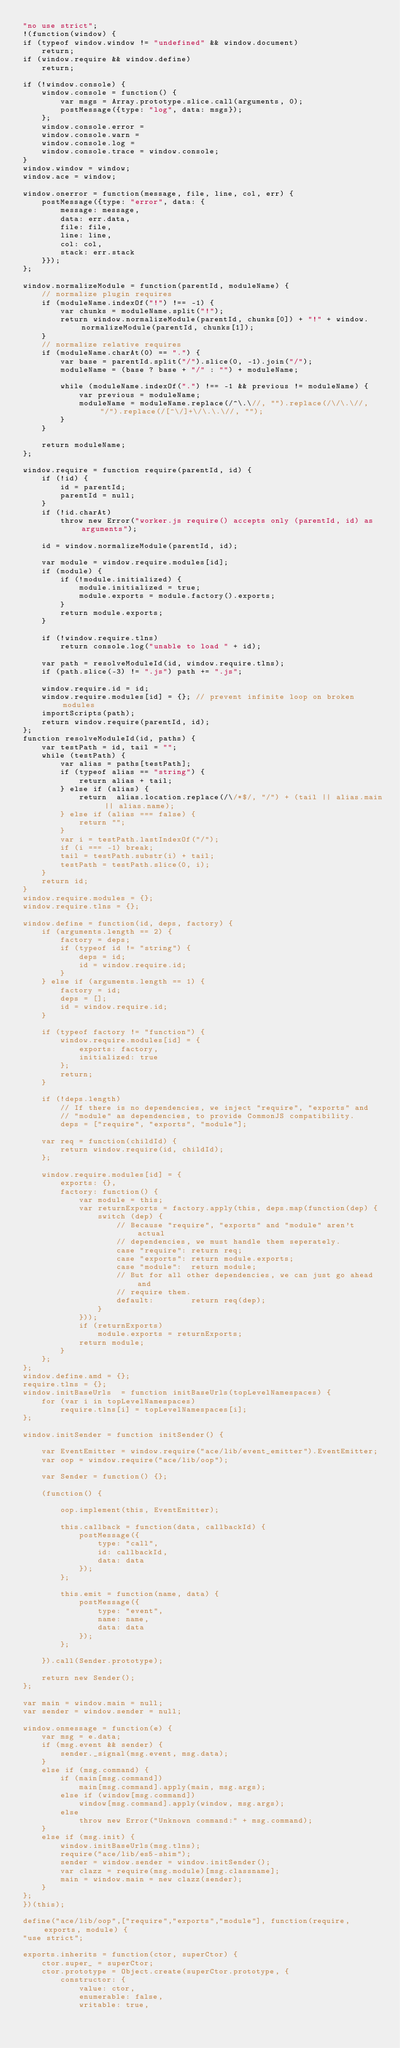Convert code to text. <code><loc_0><loc_0><loc_500><loc_500><_JavaScript_>"no use strict";
!(function(window) {
if (typeof window.window != "undefined" && window.document)
    return;
if (window.require && window.define)
    return;

if (!window.console) {
    window.console = function() {
        var msgs = Array.prototype.slice.call(arguments, 0);
        postMessage({type: "log", data: msgs});
    };
    window.console.error =
    window.console.warn = 
    window.console.log =
    window.console.trace = window.console;
}
window.window = window;
window.ace = window;

window.onerror = function(message, file, line, col, err) {
    postMessage({type: "error", data: {
        message: message,
        data: err.data,
        file: file,
        line: line, 
        col: col,
        stack: err.stack
    }});
};

window.normalizeModule = function(parentId, moduleName) {
    // normalize plugin requires
    if (moduleName.indexOf("!") !== -1) {
        var chunks = moduleName.split("!");
        return window.normalizeModule(parentId, chunks[0]) + "!" + window.normalizeModule(parentId, chunks[1]);
    }
    // normalize relative requires
    if (moduleName.charAt(0) == ".") {
        var base = parentId.split("/").slice(0, -1).join("/");
        moduleName = (base ? base + "/" : "") + moduleName;
        
        while (moduleName.indexOf(".") !== -1 && previous != moduleName) {
            var previous = moduleName;
            moduleName = moduleName.replace(/^\.\//, "").replace(/\/\.\//, "/").replace(/[^\/]+\/\.\.\//, "");
        }
    }
    
    return moduleName;
};

window.require = function require(parentId, id) {
    if (!id) {
        id = parentId;
        parentId = null;
    }
    if (!id.charAt)
        throw new Error("worker.js require() accepts only (parentId, id) as arguments");

    id = window.normalizeModule(parentId, id);

    var module = window.require.modules[id];
    if (module) {
        if (!module.initialized) {
            module.initialized = true;
            module.exports = module.factory().exports;
        }
        return module.exports;
    }
   
    if (!window.require.tlns)
        return console.log("unable to load " + id);
    
    var path = resolveModuleId(id, window.require.tlns);
    if (path.slice(-3) != ".js") path += ".js";
    
    window.require.id = id;
    window.require.modules[id] = {}; // prevent infinite loop on broken modules
    importScripts(path);
    return window.require(parentId, id);
};
function resolveModuleId(id, paths) {
    var testPath = id, tail = "";
    while (testPath) {
        var alias = paths[testPath];
        if (typeof alias == "string") {
            return alias + tail;
        } else if (alias) {
            return  alias.location.replace(/\/*$/, "/") + (tail || alias.main || alias.name);
        } else if (alias === false) {
            return "";
        }
        var i = testPath.lastIndexOf("/");
        if (i === -1) break;
        tail = testPath.substr(i) + tail;
        testPath = testPath.slice(0, i);
    }
    return id;
}
window.require.modules = {};
window.require.tlns = {};

window.define = function(id, deps, factory) {
    if (arguments.length == 2) {
        factory = deps;
        if (typeof id != "string") {
            deps = id;
            id = window.require.id;
        }
    } else if (arguments.length == 1) {
        factory = id;
        deps = [];
        id = window.require.id;
    }
    
    if (typeof factory != "function") {
        window.require.modules[id] = {
            exports: factory,
            initialized: true
        };
        return;
    }

    if (!deps.length)
        // If there is no dependencies, we inject "require", "exports" and
        // "module" as dependencies, to provide CommonJS compatibility.
        deps = ["require", "exports", "module"];

    var req = function(childId) {
        return window.require(id, childId);
    };

    window.require.modules[id] = {
        exports: {},
        factory: function() {
            var module = this;
            var returnExports = factory.apply(this, deps.map(function(dep) {
                switch (dep) {
                    // Because "require", "exports" and "module" aren't actual
                    // dependencies, we must handle them seperately.
                    case "require": return req;
                    case "exports": return module.exports;
                    case "module":  return module;
                    // But for all other dependencies, we can just go ahead and
                    // require them.
                    default:        return req(dep);
                }
            }));
            if (returnExports)
                module.exports = returnExports;
            return module;
        }
    };
};
window.define.amd = {};
require.tlns = {};
window.initBaseUrls  = function initBaseUrls(topLevelNamespaces) {
    for (var i in topLevelNamespaces)
        require.tlns[i] = topLevelNamespaces[i];
};

window.initSender = function initSender() {

    var EventEmitter = window.require("ace/lib/event_emitter").EventEmitter;
    var oop = window.require("ace/lib/oop");
    
    var Sender = function() {};
    
    (function() {
        
        oop.implement(this, EventEmitter);
                
        this.callback = function(data, callbackId) {
            postMessage({
                type: "call",
                id: callbackId,
                data: data
            });
        };
    
        this.emit = function(name, data) {
            postMessage({
                type: "event",
                name: name,
                data: data
            });
        };
        
    }).call(Sender.prototype);
    
    return new Sender();
};

var main = window.main = null;
var sender = window.sender = null;

window.onmessage = function(e) {
    var msg = e.data;
    if (msg.event && sender) {
        sender._signal(msg.event, msg.data);
    }
    else if (msg.command) {
        if (main[msg.command])
            main[msg.command].apply(main, msg.args);
        else if (window[msg.command])
            window[msg.command].apply(window, msg.args);
        else
            throw new Error("Unknown command:" + msg.command);
    }
    else if (msg.init) {
        window.initBaseUrls(msg.tlns);
        require("ace/lib/es5-shim");
        sender = window.sender = window.initSender();
        var clazz = require(msg.module)[msg.classname];
        main = window.main = new clazz(sender);
    }
};
})(this);

define("ace/lib/oop",["require","exports","module"], function(require, exports, module) {
"use strict";

exports.inherits = function(ctor, superCtor) {
    ctor.super_ = superCtor;
    ctor.prototype = Object.create(superCtor.prototype, {
        constructor: {
            value: ctor,
            enumerable: false,
            writable: true,</code> 